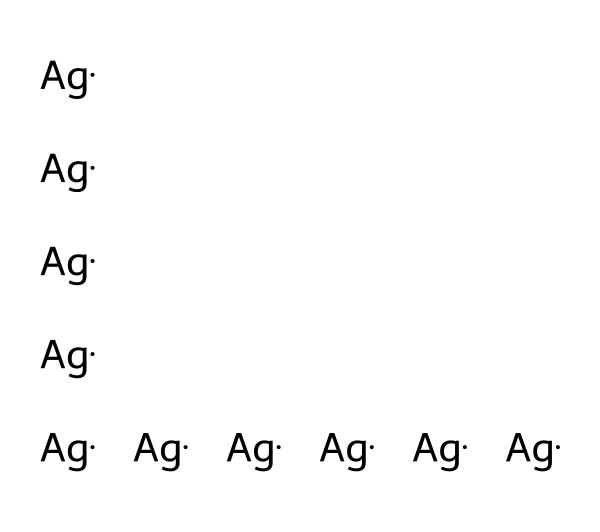What is the total number of silver atoms in the structure? The SMILES representation indicates multiple silver (Ag) atoms; by counting the number of occurrences of '[Ag]', we see there are ten present.
Answer: ten What type of chemical structure is presented here? The chemical consists solely of elemental silver atoms, indicating it is a metallic nanoparticle rather than a compound.
Answer: metallic nanoparticle How would you classify this silver nanoparticle in terms of its role in biomedical applications? Silver nanoparticles are well-known for their antimicrobial properties, thus they can be classified as antimicrobial agents used in coatings for orthopedic devices.
Answer: antimicrobial agent What is the oxidation state of silver in this structure? Since the representation shows only elemental silver without any additional information suggesting a change, the oxidation state of silver is zero.
Answer: zero How might the size of these nanoparticles affect their antimicrobial efficacy? Nanoparticle size influences their surface area to volume ratio, with smaller sizes generally providing higher surface area, which enhances interaction with microbial cells and increases antimicrobial efficacy.
Answer: increased efficacy What property of silver nanoparticles contributes to their application in orthopedic devices? The property of silver nanoparticles that contributes to their application is their ability to release silver ions, which are effective in preventing infection due to their antibacterial effects.
Answer: antibacterial effects 